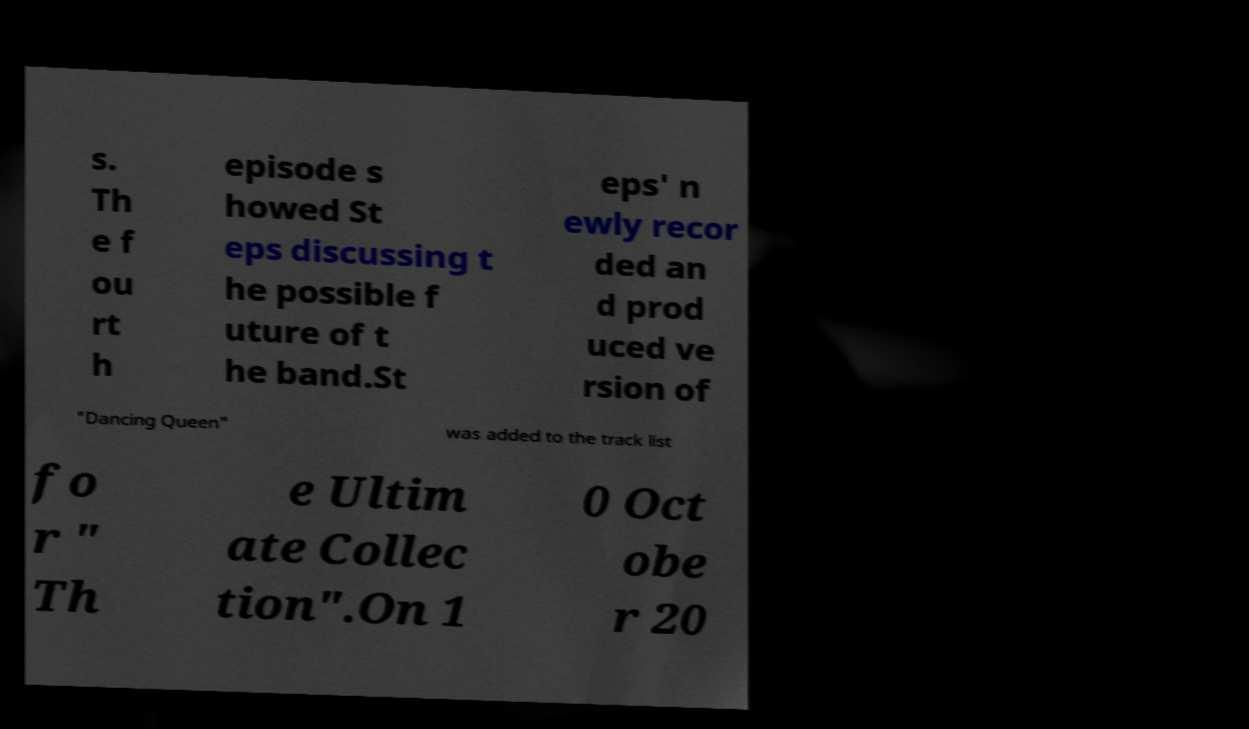Please read and relay the text visible in this image. What does it say? s. Th e f ou rt h episode s howed St eps discussing t he possible f uture of t he band.St eps' n ewly recor ded an d prod uced ve rsion of "Dancing Queen" was added to the track list fo r " Th e Ultim ate Collec tion".On 1 0 Oct obe r 20 